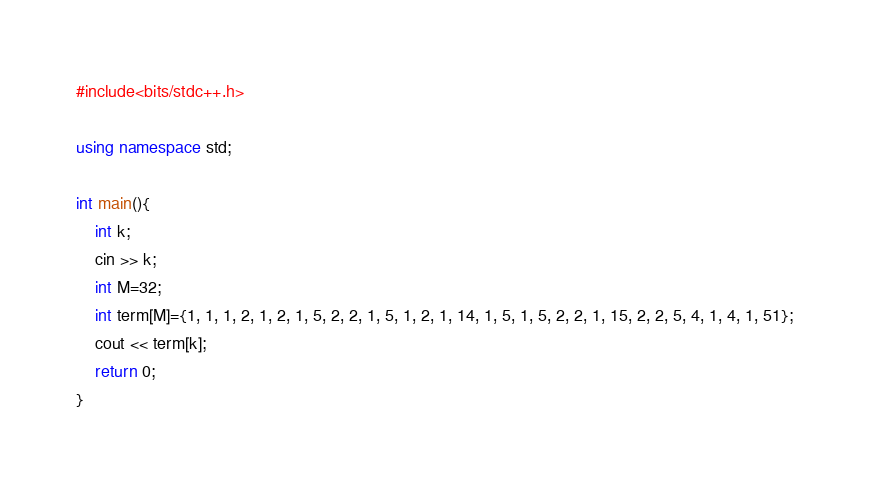<code> <loc_0><loc_0><loc_500><loc_500><_C++_>#include<bits/stdc++.h>

using namespace std;

int main(){
    int k;
    cin >> k;
    int M=32;
    int term[M]={1, 1, 1, 2, 1, 2, 1, 5, 2, 2, 1, 5, 1, 2, 1, 14, 1, 5, 1, 5, 2, 2, 1, 15, 2, 2, 5, 4, 1, 4, 1, 51};
    cout << term[k];
    return 0;
}
</code> 